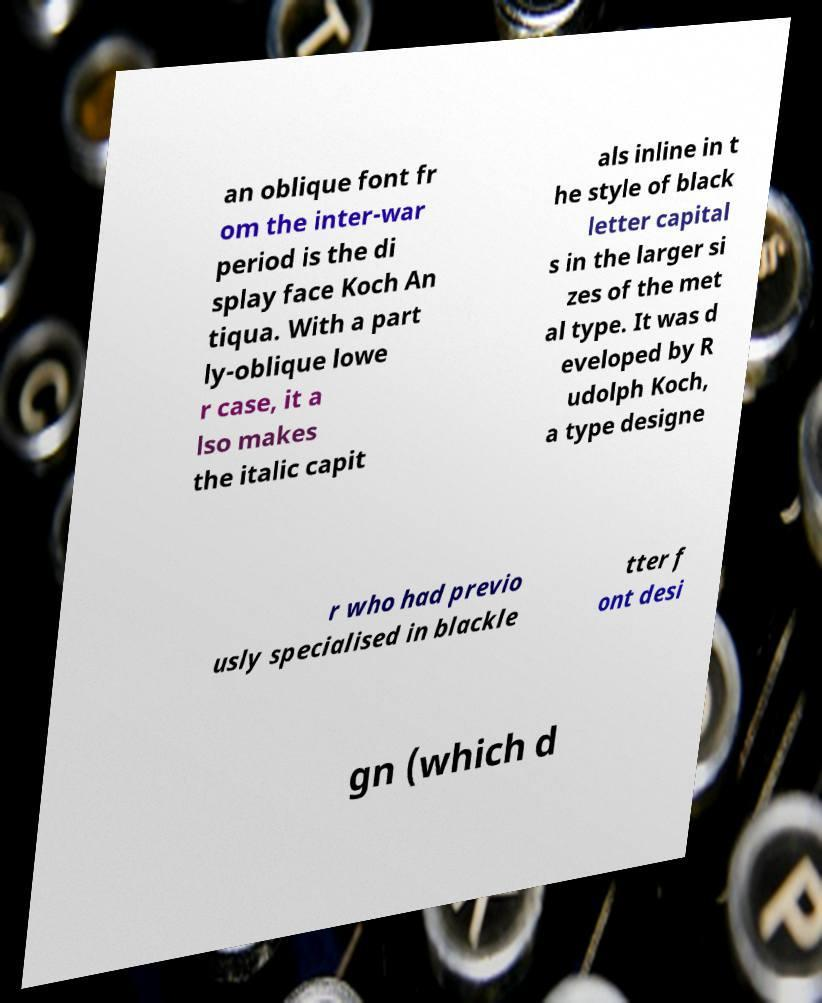Please identify and transcribe the text found in this image. an oblique font fr om the inter-war period is the di splay face Koch An tiqua. With a part ly-oblique lowe r case, it a lso makes the italic capit als inline in t he style of black letter capital s in the larger si zes of the met al type. It was d eveloped by R udolph Koch, a type designe r who had previo usly specialised in blackle tter f ont desi gn (which d 